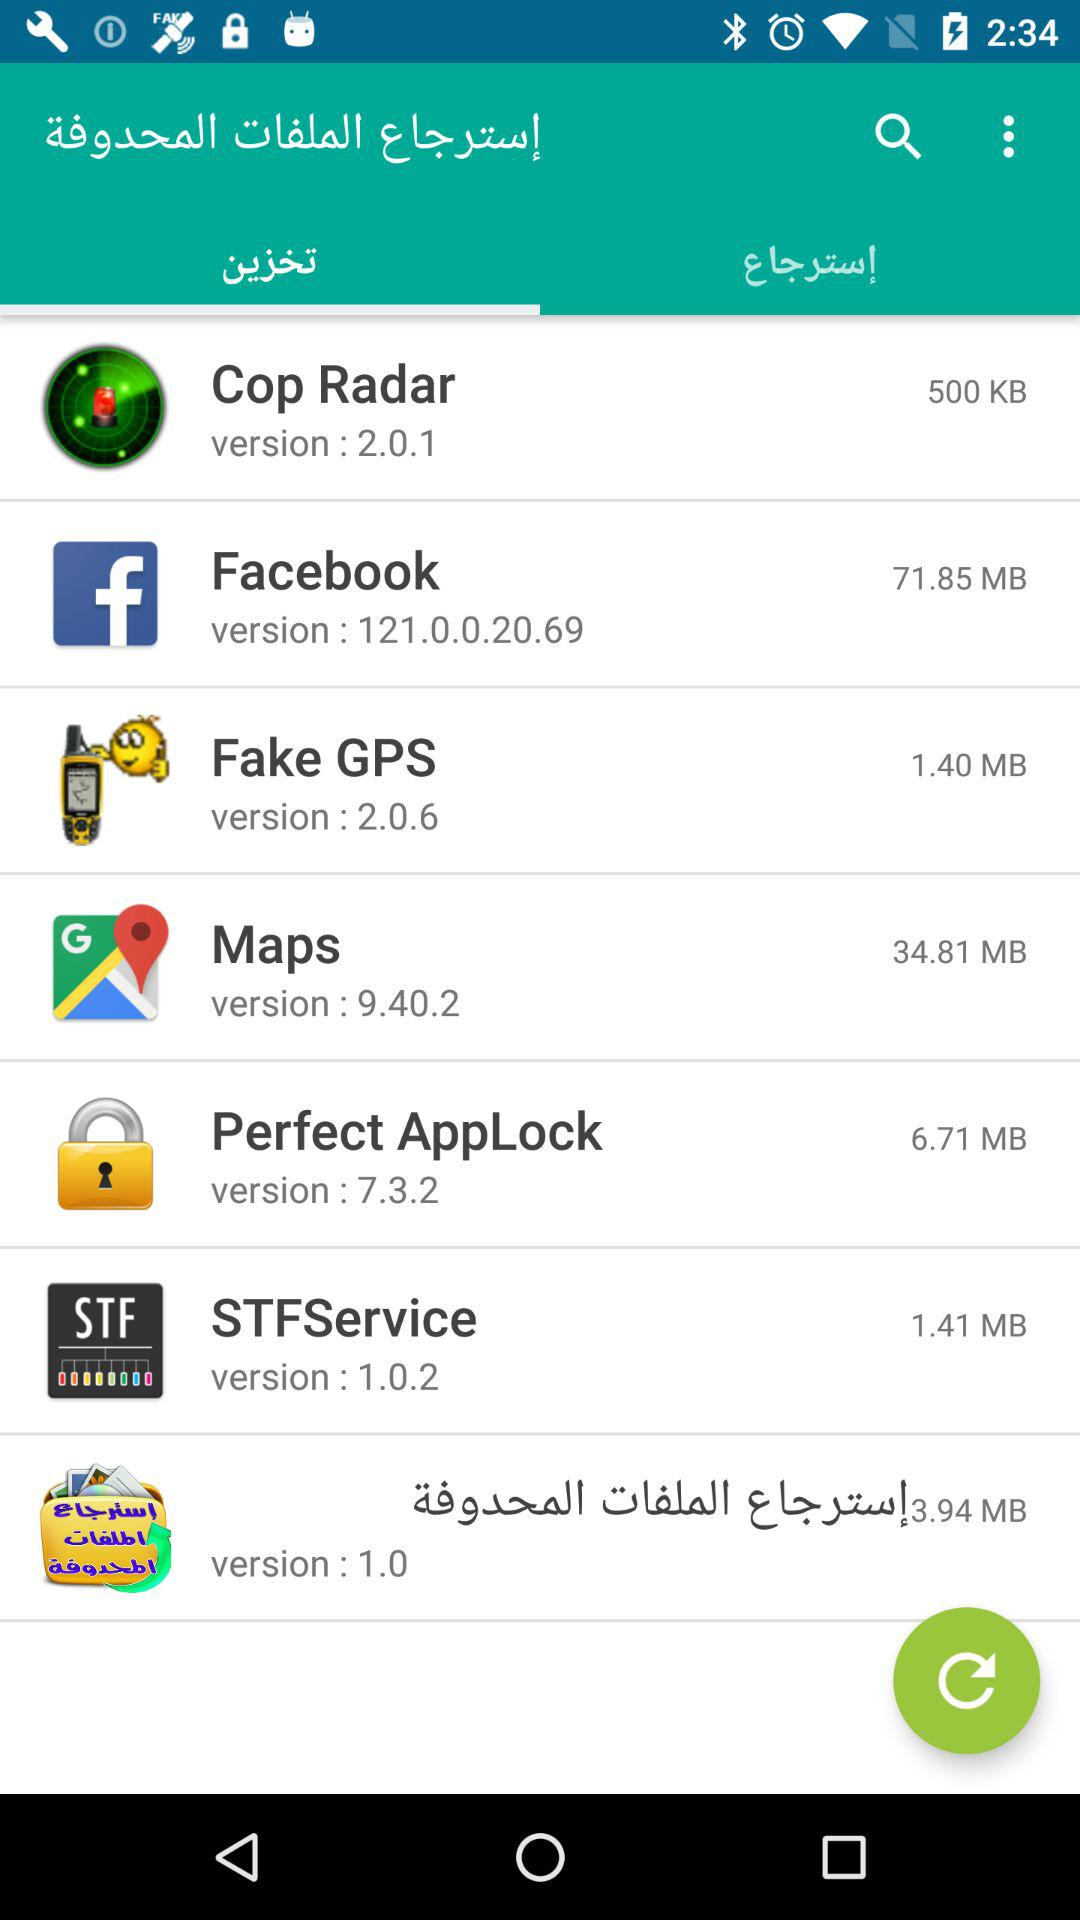How much space is consumed by "Cop Radar"? The space consumed by "Cop Radar" is 500 KB. 